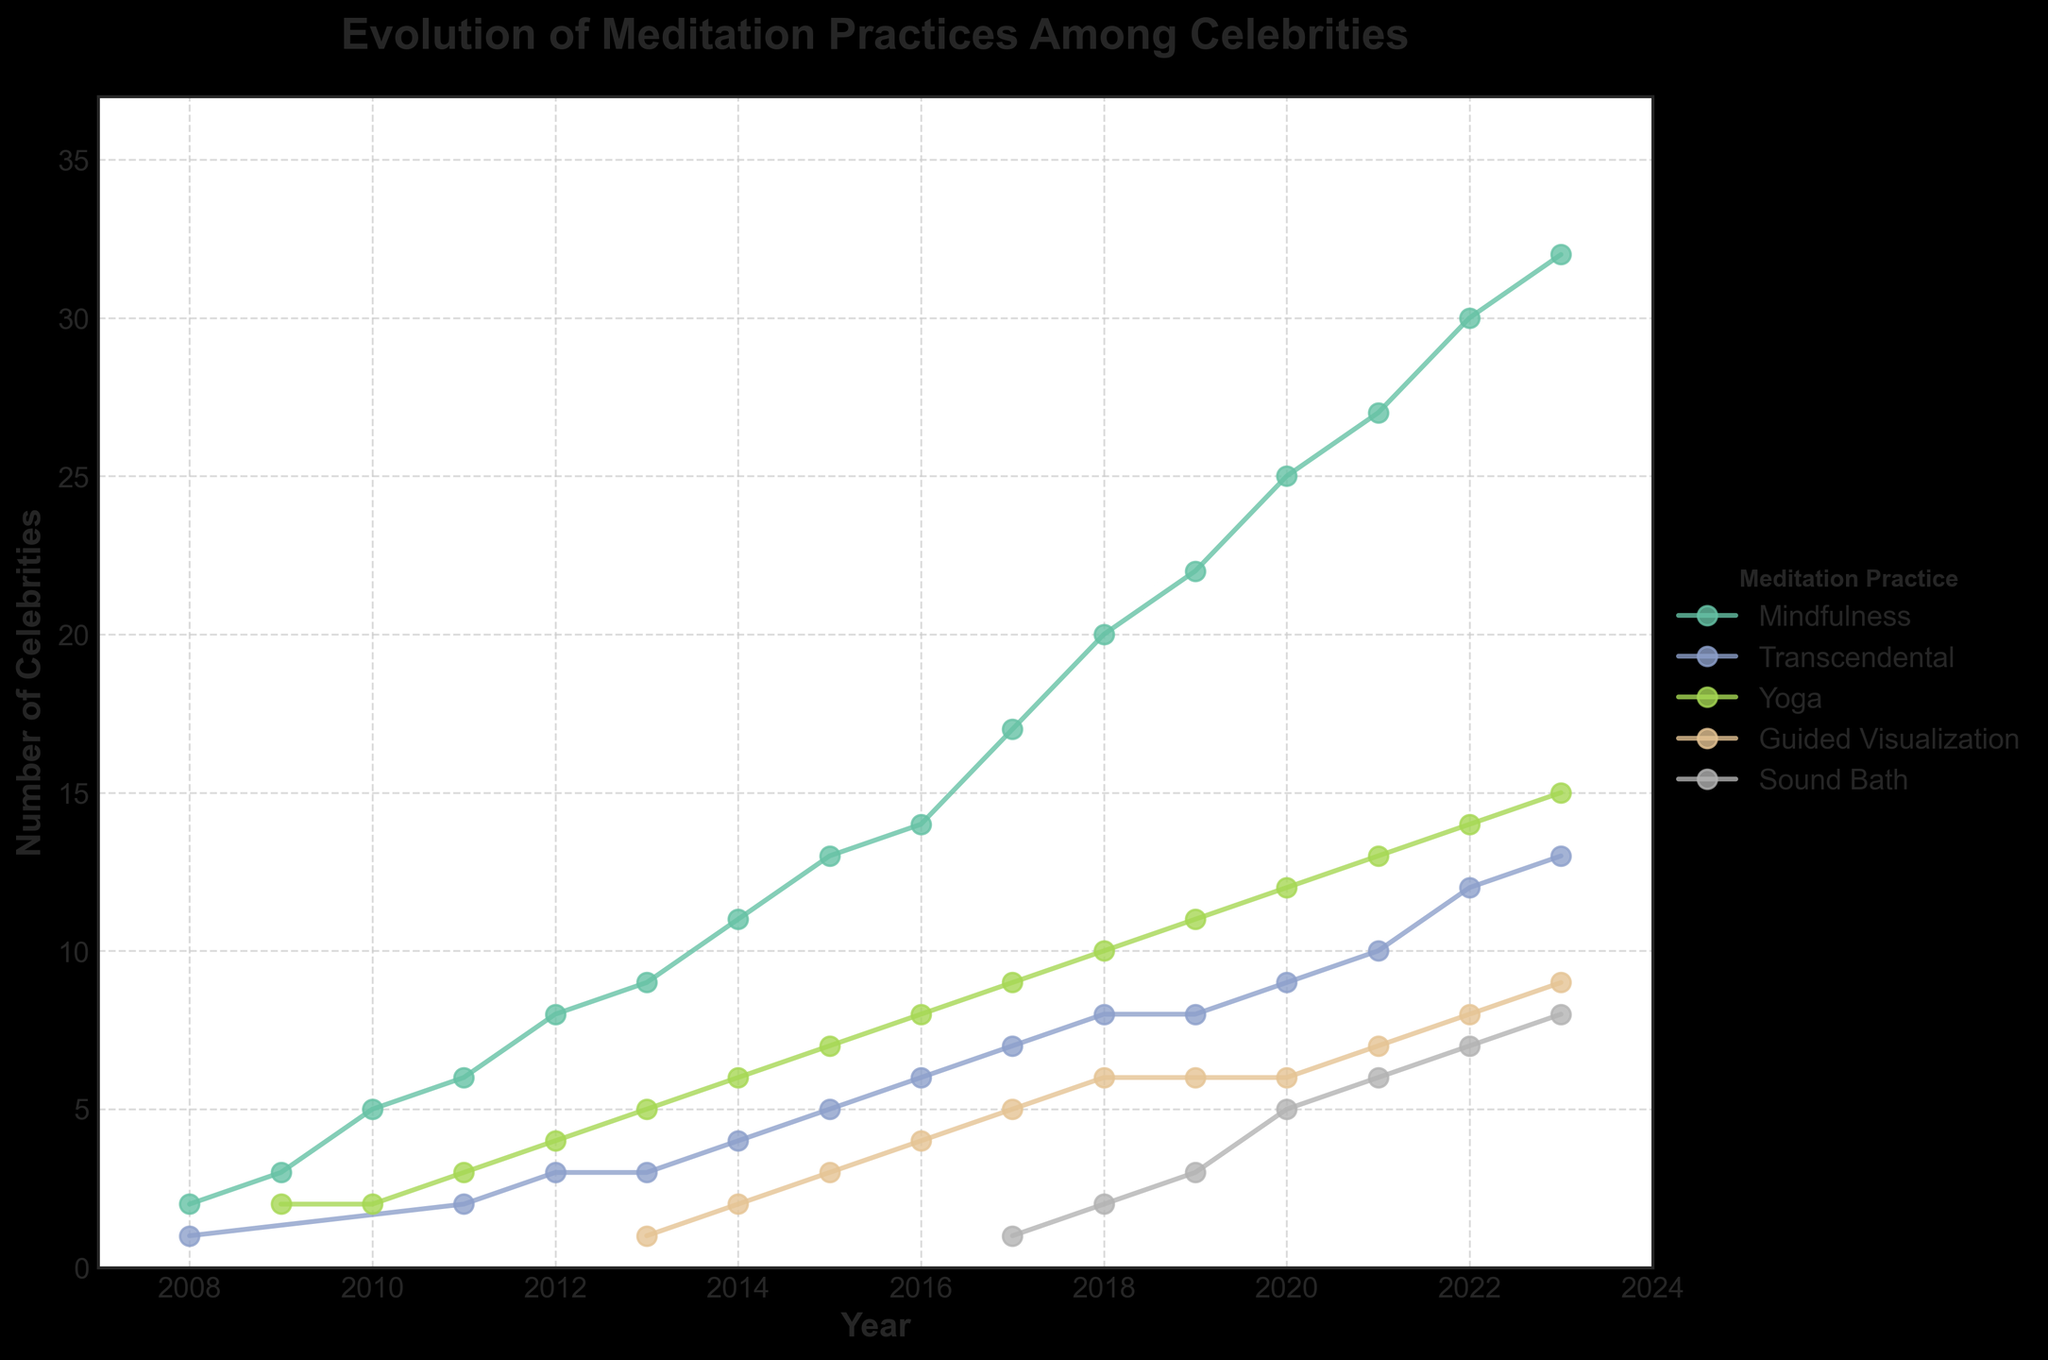What is the title of the figure? The title is usually located at the top of the figure. It provides a summary of what the visual represents.
Answer: Evolution of Meditation Practices Among Celebrities How many different meditation practices are displayed in the figure? Examine the legend, which shows all represented meditation practices. Count the distinct practices listed.
Answer: 5 Which meditation practice had the highest number of celebrity adopters in 2023? Locate the data points on the right side of the timeline for 2023 and identify which practice has the highest number of celebrities.
Answer: Mindfulness In which year did the Sound Bath practice first appear among the celebrities? Trace back the line corresponding to the Sound Bath practice to find the earliest year it is represented on the plot.
Answer: 2017 Which meditation practice shows the most consistent increase in the number of celebrities from 2008 to 2023? Observe the slopes of the lines for each meditation practice. The practice with the most consistent upward trend is identified by the least fluctuations and a steady increase.
Answer: Mindfulness What is the difference in the number of celebrity adopters of Guided Visualization between 2020 and 2023? Find the data points for Guided Visualization in 2020 and 2023, then subtract the 2020 value from the 2023 value.
Answer: 3 Compare the number of celebrity adopters of Yoga in 2010 and 2022. Which year had more adopters, and by how much? Look at the data points for Yoga in 2010 and 2022. Calculate the difference by subtracting the 2010 value from the 2022 value.
Answer: 2022 had 12 more adopters Which year saw the highest increase in the number of celebrities practicing Transcendental meditation from the previous year? Observe the Transcendental meditation line and find the year-to-year differences. The highest increase is determined by the largest positive difference.
Answer: 2022 What has been the trend in the number of celebrity adopters for Yoga over the 15 years? Examine the Yoga line from 2008 to 2023, and describe the overall pattern observed, whether it is increasing, decreasing, or fluctuating.
Answer: Increasing What's the average number of celebrity adopters for Sound Bath from 2017 to 2023? Sum the number of Sound Bath adopters from 2017 to 2023, then divide by the number of years (7).
Answer: 4.57 